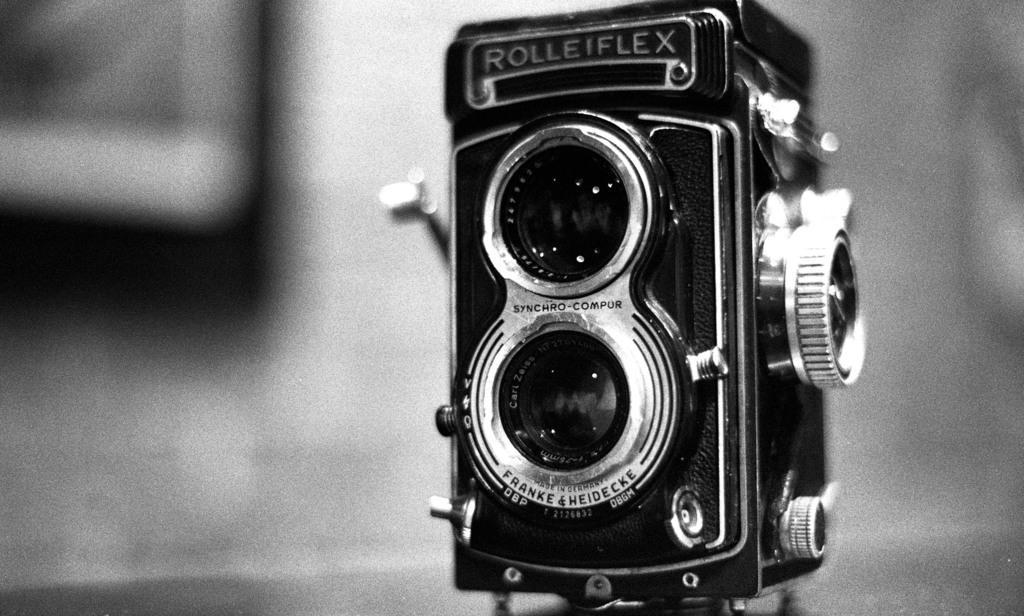In one or two sentences, can you explain what this image depicts? This is black and white image where we can see a camera with some text written on it. The background is blurry. 